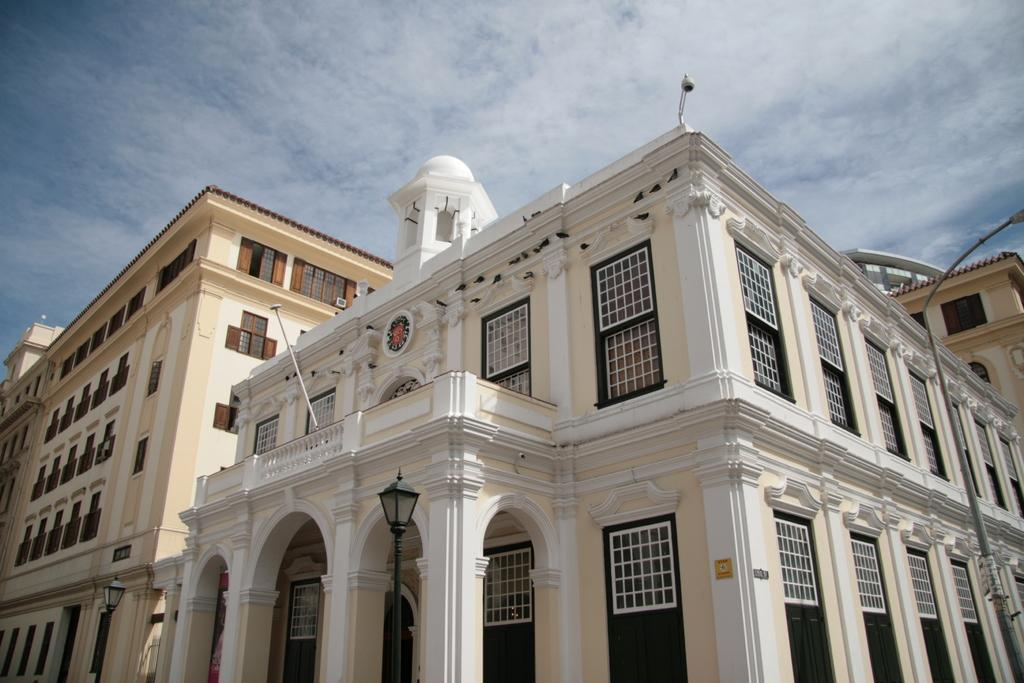What is the main subject of the image? The main subject of the image is buildings. Where are the buildings located in the image? The buildings are in the center of the image. What can be seen in the background of the image? Sky and clouds are visible in the background of the image. What type of sofa can be seen in the image? There is no sofa present in the image. What is the town's name in the image? The image does not provide any information about the town's name. 